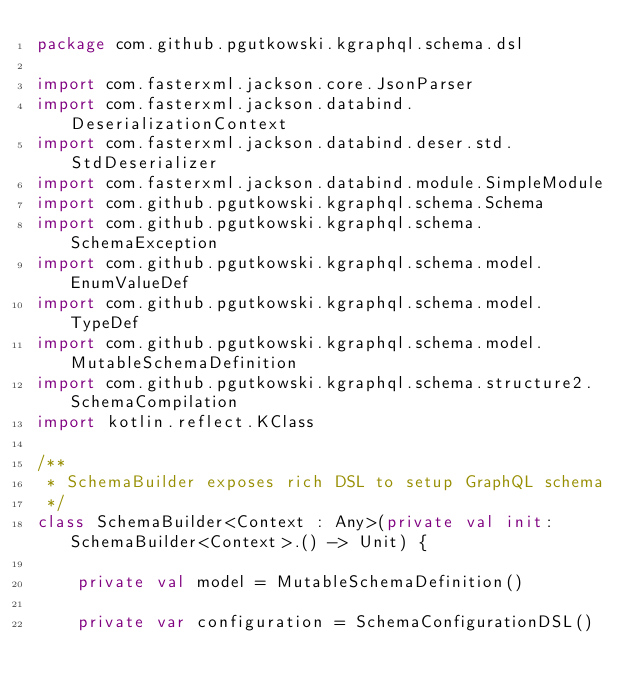Convert code to text. <code><loc_0><loc_0><loc_500><loc_500><_Kotlin_>package com.github.pgutkowski.kgraphql.schema.dsl

import com.fasterxml.jackson.core.JsonParser
import com.fasterxml.jackson.databind.DeserializationContext
import com.fasterxml.jackson.databind.deser.std.StdDeserializer
import com.fasterxml.jackson.databind.module.SimpleModule
import com.github.pgutkowski.kgraphql.schema.Schema
import com.github.pgutkowski.kgraphql.schema.SchemaException
import com.github.pgutkowski.kgraphql.schema.model.EnumValueDef
import com.github.pgutkowski.kgraphql.schema.model.TypeDef
import com.github.pgutkowski.kgraphql.schema.model.MutableSchemaDefinition
import com.github.pgutkowski.kgraphql.schema.structure2.SchemaCompilation
import kotlin.reflect.KClass

/**
 * SchemaBuilder exposes rich DSL to setup GraphQL schema
 */
class SchemaBuilder<Context : Any>(private val init: SchemaBuilder<Context>.() -> Unit) {

    private val model = MutableSchemaDefinition()

    private var configuration = SchemaConfigurationDSL()
</code> 